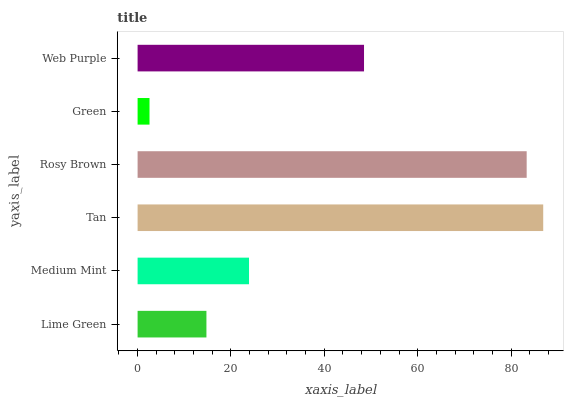Is Green the minimum?
Answer yes or no. Yes. Is Tan the maximum?
Answer yes or no. Yes. Is Medium Mint the minimum?
Answer yes or no. No. Is Medium Mint the maximum?
Answer yes or no. No. Is Medium Mint greater than Lime Green?
Answer yes or no. Yes. Is Lime Green less than Medium Mint?
Answer yes or no. Yes. Is Lime Green greater than Medium Mint?
Answer yes or no. No. Is Medium Mint less than Lime Green?
Answer yes or no. No. Is Web Purple the high median?
Answer yes or no. Yes. Is Medium Mint the low median?
Answer yes or no. Yes. Is Green the high median?
Answer yes or no. No. Is Tan the low median?
Answer yes or no. No. 